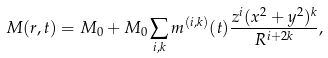<formula> <loc_0><loc_0><loc_500><loc_500>M ( r , t ) = M _ { 0 } + M _ { 0 } \sum _ { i , k } m ^ { ( i , k ) } ( t ) \frac { z ^ { i } ( x ^ { 2 } + y ^ { 2 } ) ^ { k } } { R ^ { i + 2 k } } ,</formula> 